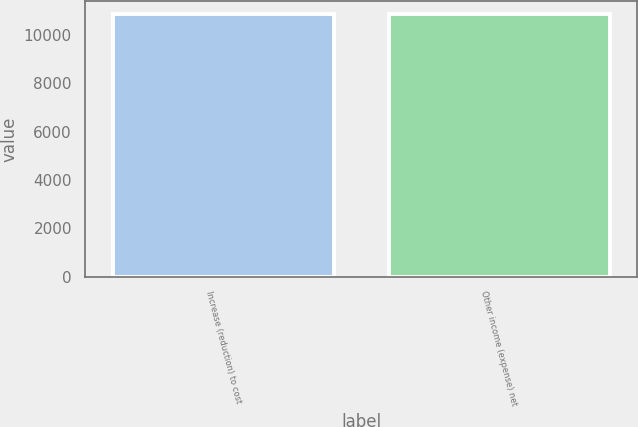Convert chart to OTSL. <chart><loc_0><loc_0><loc_500><loc_500><bar_chart><fcel>Increase (reduction) to cost<fcel>Other income (expense) net<nl><fcel>10856<fcel>10856.1<nl></chart> 